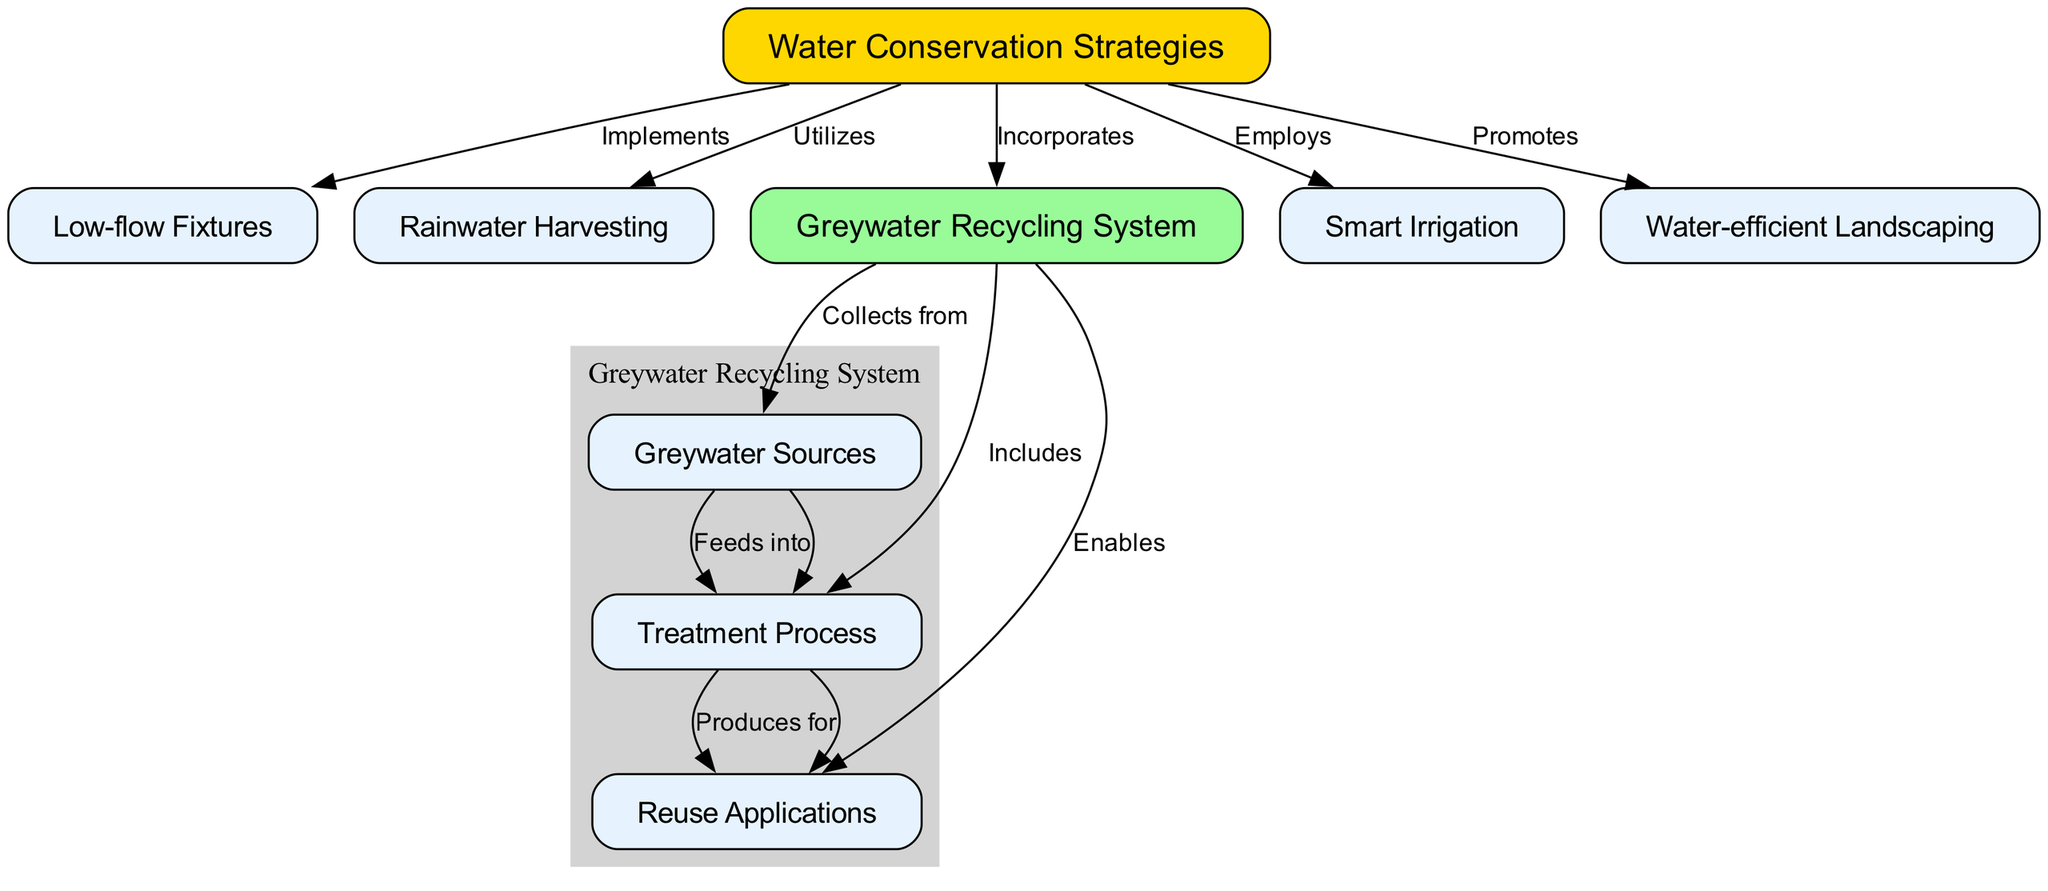What is the primary focus of the diagram? The primary focus of the diagram is "Water Conservation Strategies", which is represented as the central node in the diagram. This node is connected to various related strategies and systems indicating its significance in the context of water conservation in buildings.
Answer: Water Conservation Strategies How many nodes are dedicated to greywater recycling? There are four nodes related to greywater recycling, indicated by the connections stemming from the "Greywater Recycling System" node, which includes "Greywater Sources," "Treatment Process," and "Reuse Applications." This counts the graywater node itself.
Answer: Four What type of fixtures does the Water Conservation Strategies node implement? The Water Conservation Strategies node implements "Low-flow Fixtures," which is directly connected to it as indicated by the edge labeled "Implements."
Answer: Low-flow Fixtures Which strategy directly utilizes Rainwater? The node that utilizes rainwater is the "Water Conservation Strategies" node, which is indicated by the directed edge labeled "Utilizes" connecting it to "Rainwater Harvesting."
Answer: Water Conservation Strategies What does the Greywater Recycling System collect from? The Greywater Recycling System collects from "Greywater Sources," which is shown by the directed edge labeled "Collects from" connecting it to the respective node.
Answer: Greywater Sources What is produced for reuse applications in the greywater system? The "Reuse Applications" node is produced for by "Treatment Process," indicated by the directed edge labeled "Produces for" connecting these two nodes.
Answer: Reuse Applications Which water conservation strategy is associated with landscaping? The strategy associated with landscaping is "Water-efficient Landscaping," which is linked to the main node "Water Conservation Strategies" by the edge labeled "Promotes."
Answer: Water-efficient Landscaping How many methods are used under Water Conservation Strategies to reduce water usage? There are five methods indicated in the diagram under Water Conservation Strategies: "Low-flow Fixtures," "Rainwater Harvesting," "Greywater Recycling System," "Smart Irrigation," and "Water-efficient Landscaping." Counted together, they form a group of five methods for reducing water usage.
Answer: Five 